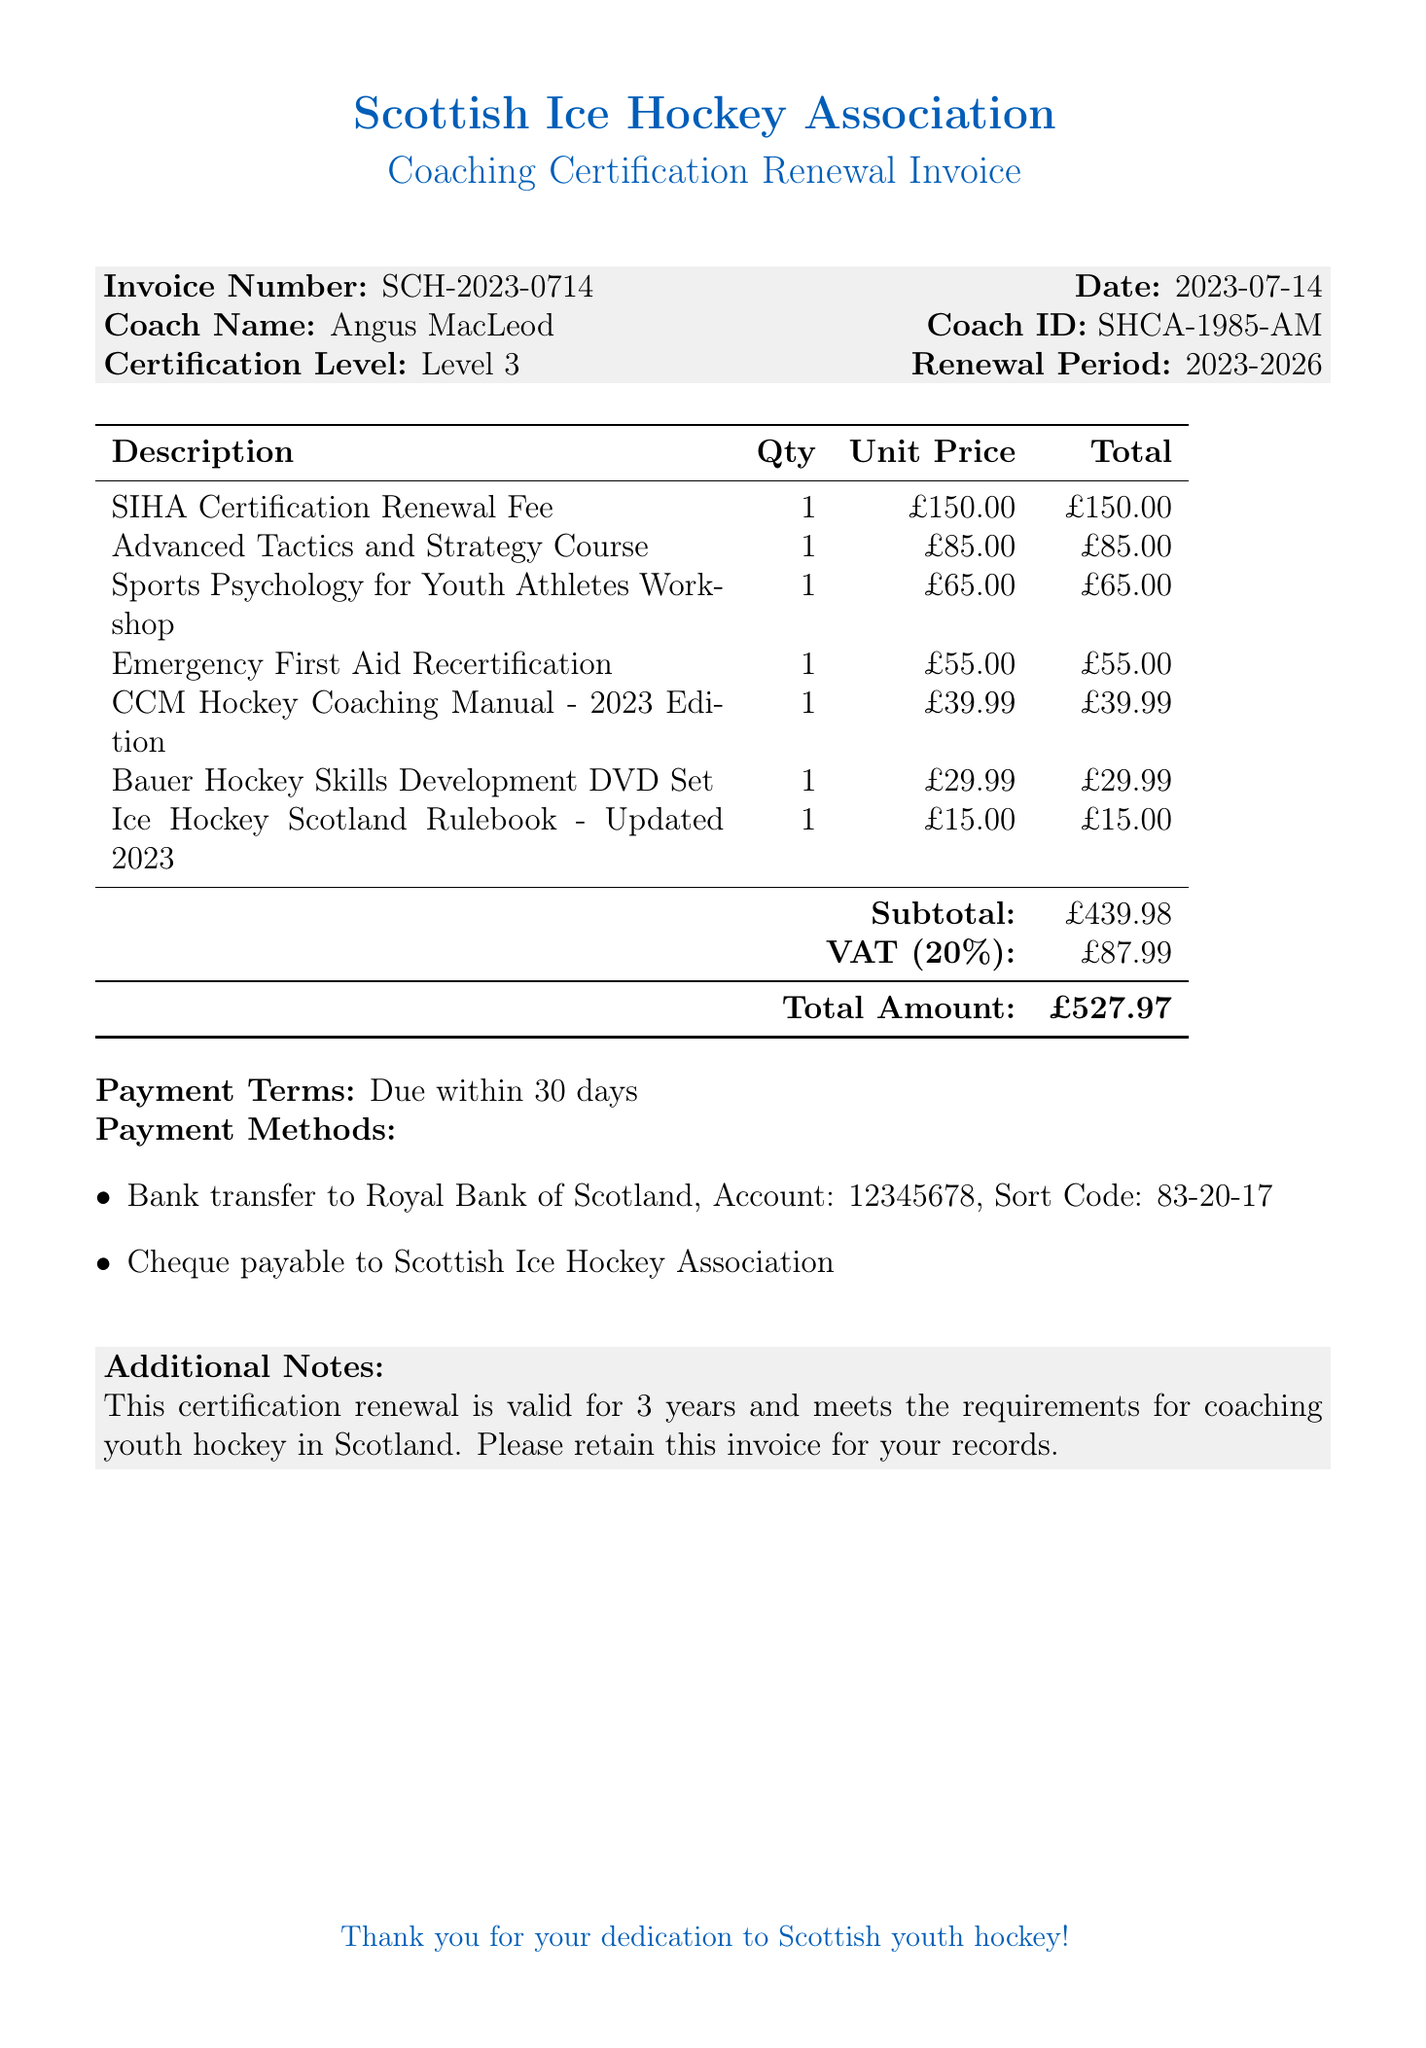What is the invoice number? The invoice number is a unique identifier for the invoice, which is provided in the document.
Answer: SCH-2023-0714 What is the total amount due? The total amount due is the final amount that needs to be paid, as specified at the bottom of the invoice.
Answer: £527.97 Who is the coach named on the invoice? The coach's name is listed prominently near the top of the invoice, indicating to whom the invoice is addressed.
Answer: Angus MacLeod What certification level is mentioned? The certification level indicates the qualification the coach holds and is specified in the document.
Answer: Level 3 How long is the renewal period for the certification? The renewal period indicates the duration for which the certification is valid, found in the details of the invoice.
Answer: 2023-2026 What is the unit price of the Sports Psychology for Youth Athletes Workshop? The unit price shows the cost of the workshop separately, which is itemized in the list of charges.
Answer: £65.00 How many items are listed on the invoice? The number of items reflects how many different courses and materials are included in the invoice.
Answer: 7 What payment terms are specified in the invoice? The payment terms outline when the payment is expected to be made, which is listed at the end of the document.
Answer: Due within 30 days What is the VAT rate applied to the total amount? The VAT rate shows the percentage of tax applied to the invoice total, which is detailed in the calculation section.
Answer: 20% 